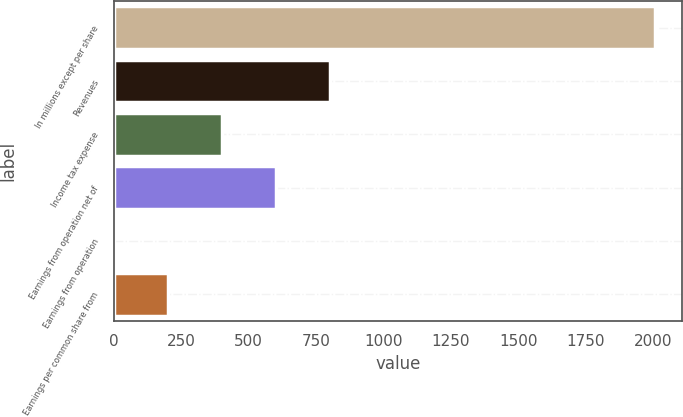<chart> <loc_0><loc_0><loc_500><loc_500><bar_chart><fcel>In millions except per share<fcel>Revenues<fcel>Income tax expense<fcel>Earnings from operation net of<fcel>Earnings from operation<fcel>Earnings per common share from<nl><fcel>2006<fcel>802.42<fcel>401.22<fcel>601.82<fcel>0.02<fcel>200.62<nl></chart> 